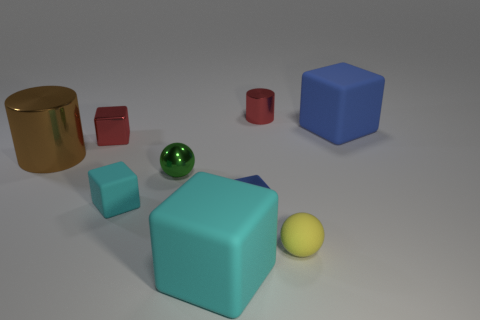Is the shape of the rubber object that is behind the big brown metal cylinder the same as the big object that is in front of the large brown metallic thing?
Your answer should be very brief. Yes. Are there the same number of matte blocks that are on the left side of the large brown metallic cylinder and brown metal things that are left of the small red metallic block?
Provide a succinct answer. No. There is a green metal thing that is to the left of the red object behind the big rubber block behind the yellow rubber object; what shape is it?
Provide a short and direct response. Sphere. Do the cylinder that is right of the small cyan matte block and the blue cube that is in front of the large brown cylinder have the same material?
Keep it short and to the point. Yes. What shape is the cyan object that is behind the yellow matte object?
Offer a very short reply. Cube. Is the number of spheres less than the number of tiny brown matte blocks?
Offer a terse response. No. Is there a ball behind the tiny shiny block that is in front of the metallic cylinder on the left side of the shiny sphere?
Your response must be concise. Yes. How many shiny objects are tiny yellow balls or small brown balls?
Provide a short and direct response. 0. Do the large metallic cylinder and the tiny metal ball have the same color?
Your answer should be very brief. No. There is a green metallic ball; what number of rubber blocks are behind it?
Provide a succinct answer. 1. 